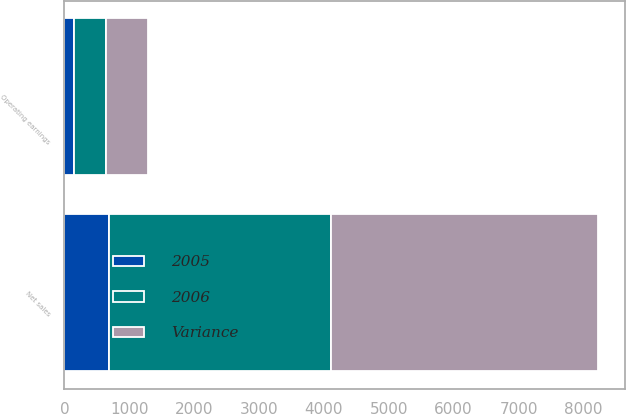Convert chart. <chart><loc_0><loc_0><loc_500><loc_500><stacked_bar_chart><ecel><fcel>Net sales<fcel>Operating earnings<nl><fcel>Variance<fcel>4116<fcel>644<nl><fcel>2006<fcel>3433<fcel>495<nl><fcel>2005<fcel>683<fcel>149<nl></chart> 